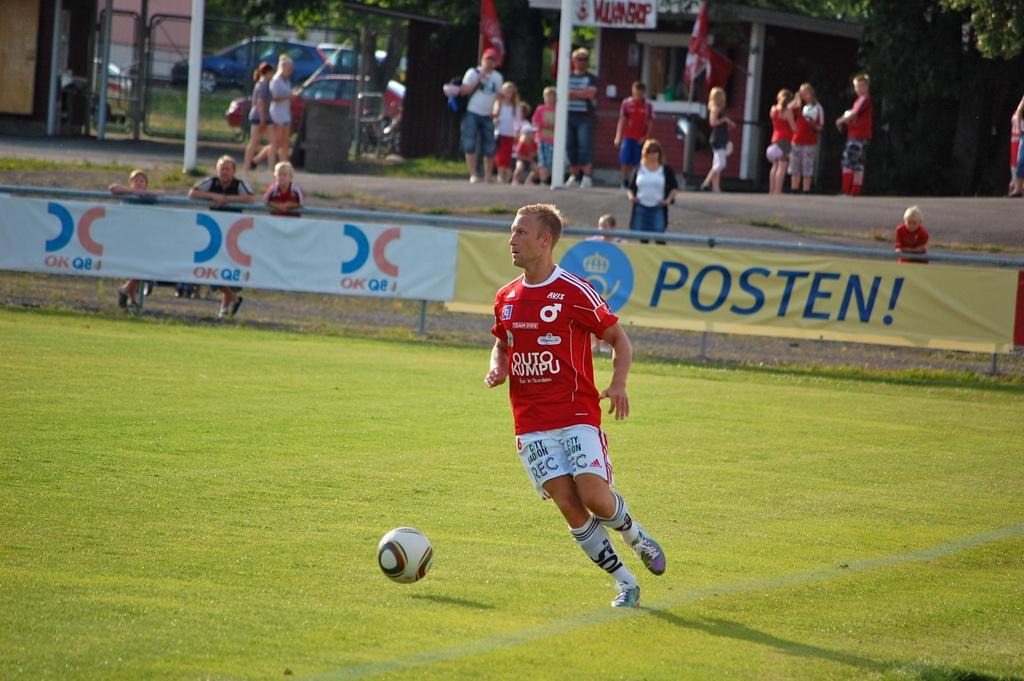Who sponsors the soccer team?
Offer a very short reply. Posten. 